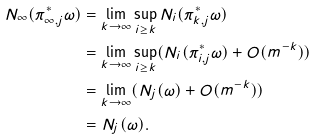Convert formula to latex. <formula><loc_0><loc_0><loc_500><loc_500>N _ { \infty } ( \pi _ { \infty , j } ^ { * } \omega ) & = \lim _ { k \to \infty } \sup _ { i \geq k } N _ { i } ( \pi _ { k , j } ^ { * } \omega ) \\ & = \lim _ { k \to \infty } \sup _ { i \geq k } ( N _ { i } ( \pi _ { i , j } ^ { * } \omega ) + O ( m ^ { - k } ) ) \\ & = \lim _ { k \to \infty } ( N _ { j } ( \omega ) + O ( m ^ { - k } ) ) \\ & = N _ { j } ( \omega ) .</formula> 